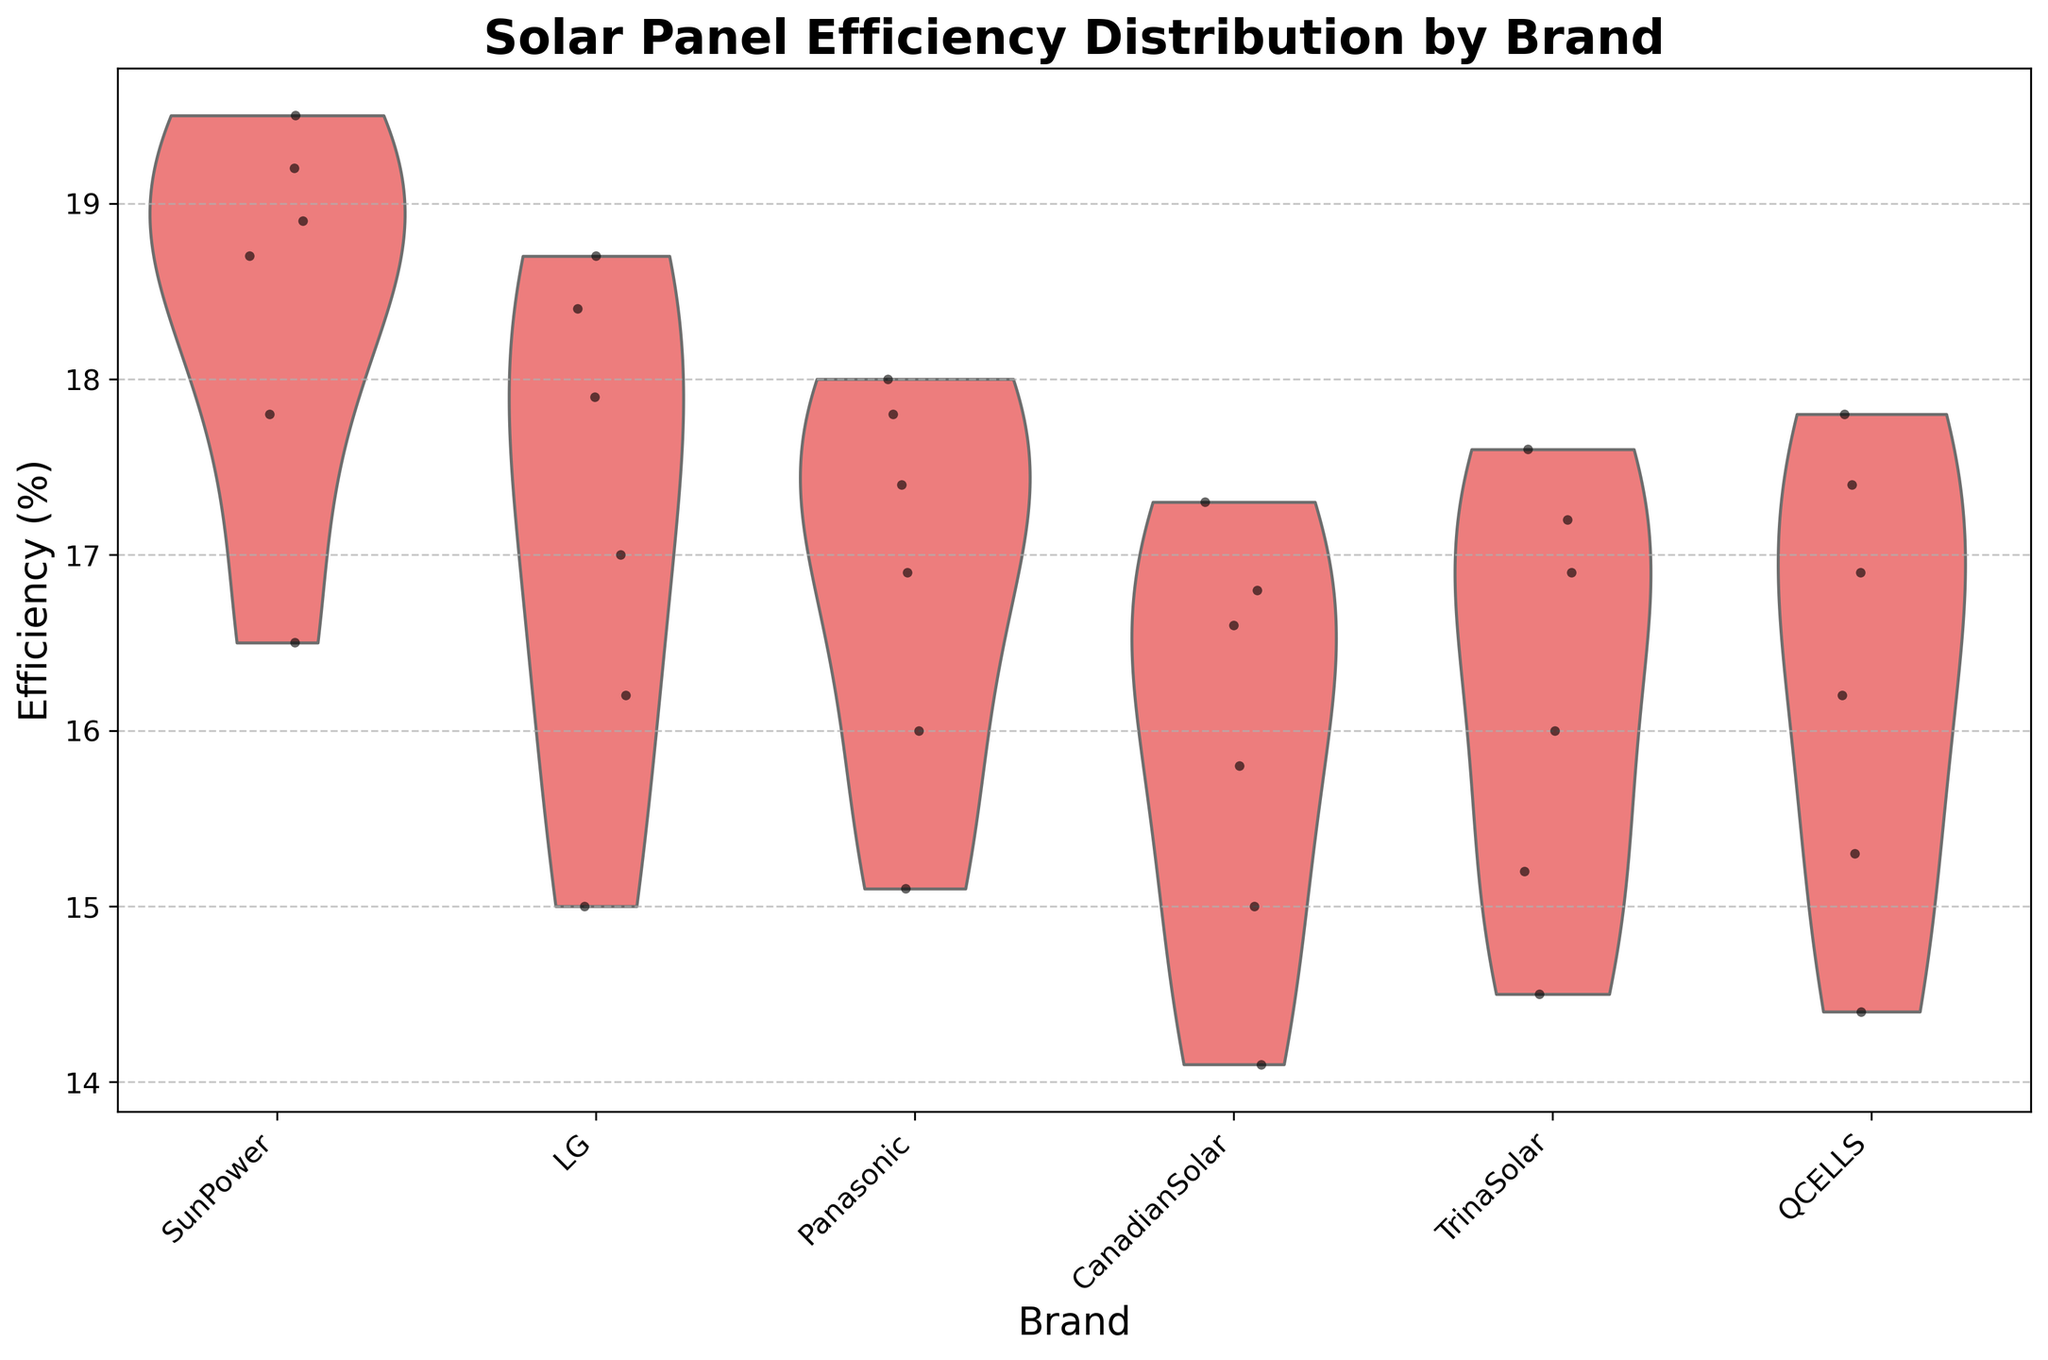What is the title of the figure? The title is usually located at the top center of the figure and provides the main description of what the figure represents. By looking at the top of the chart, the title reads "Solar Panel Efficiency Distribution by Brand".
Answer: Solar Panel Efficiency Distribution by Brand How many brands are represented in the figure? By counting the distinct groups along the x-axis, we see six brands listed: SunPower, LG, Panasonic, CanadianSolar, TrinaSolar, and QCELLS.
Answer: 6 Which brand shows the highest median efficiency? In a violin plot, the median is typically represented by the thickest part of the violin. By observing the thickest part of each violin, SunPower has the highest median efficiency.
Answer: SunPower What is the range of efficiency values for CanadianSolar? The range is the difference between the maximum and minimum values. The violin plot shows CanadianSolar's efficiency values ranging from around 14.1% to 17.3%.
Answer: 14.1% to 17.3% Compare the median efficiency of SunPower and LG. Which is higher? By comparing the thickest parts of the violins for SunPower and LG, we observe that SunPower has a higher median efficiency than LG.
Answer: SunPower Which brand has the widest spread of efficiency values? The spread is indicated by the width of the violin. By observing the width, SunPower has the widest spread of efficiency values.
Answer: SunPower Do any brands have overlapping efficiency ranges? If so, which ones? By observing the violin plots, especially noting where they overlap along the y-axis, SunPower and LG have overlapping efficiency ranges.
Answer: SunPower and LG What is the general trend of efficiency values as ambient temperature increases for SunPower? The jittered points and violin shape show that as temperature increases, the efficiency values for SunPower tend to decrease.
Answer: Decrease Among TrinaSolar and QCELLS, which brand has lower efficiency values at higher ambient temperatures? By examining the jittered points and violin end at around higher temperatures on the y-axis, QCELLS has lower efficiency values compared to TrinaSolar.
Answer: QCELLS 